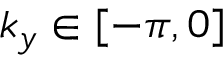Convert formula to latex. <formula><loc_0><loc_0><loc_500><loc_500>k _ { y } \in [ - \pi , 0 ]</formula> 